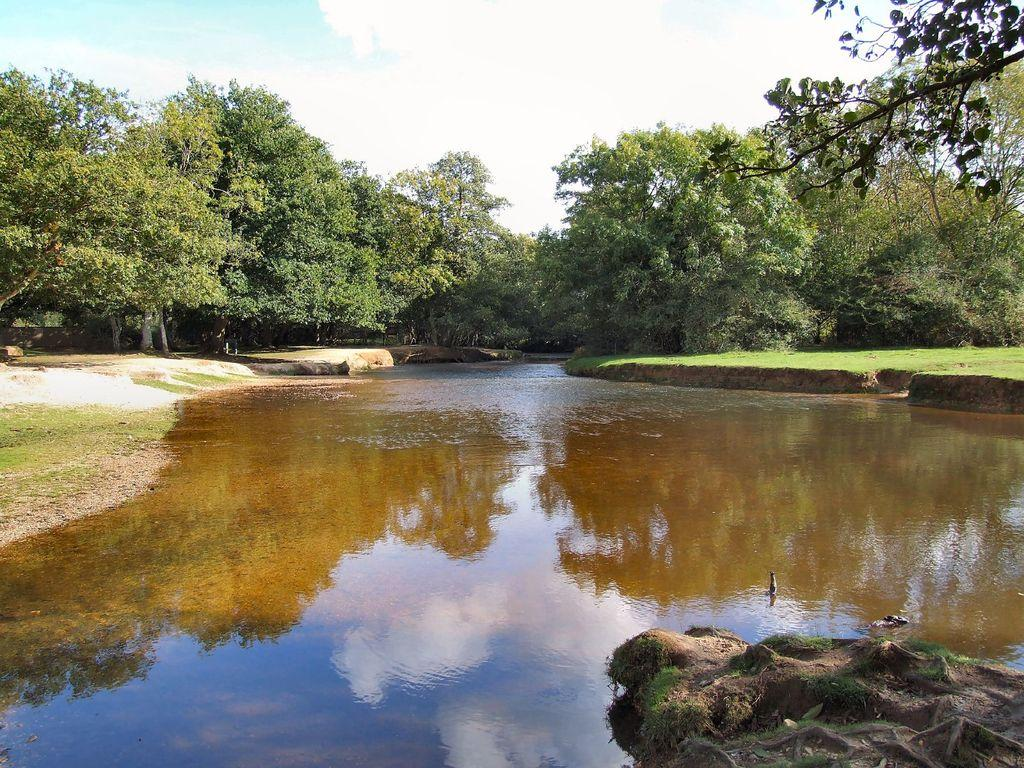What is the main feature in the middle of the image? There is a small water pond in the middle of the image. What can be seen on both sides of the water pond? There are trees on both sides of the water pond. What type of afterthought is present in the image? There is no mention of an afterthought in the image; it features a small water pond with trees on both sides. 